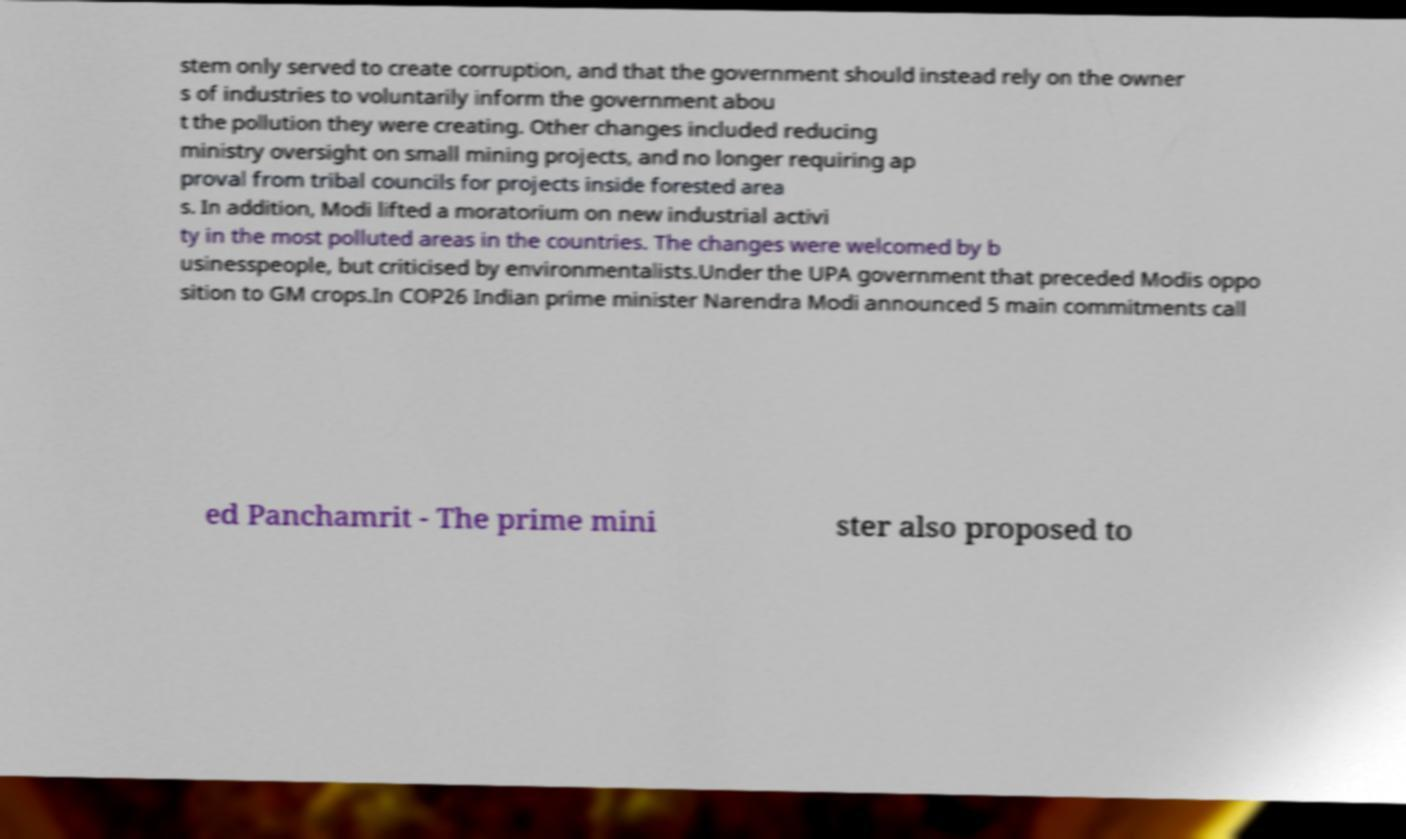There's text embedded in this image that I need extracted. Can you transcribe it verbatim? stem only served to create corruption, and that the government should instead rely on the owner s of industries to voluntarily inform the government abou t the pollution they were creating. Other changes included reducing ministry oversight on small mining projects, and no longer requiring ap proval from tribal councils for projects inside forested area s. In addition, Modi lifted a moratorium on new industrial activi ty in the most polluted areas in the countries. The changes were welcomed by b usinesspeople, but criticised by environmentalists.Under the UPA government that preceded Modis oppo sition to GM crops.In COP26 Indian prime minister Narendra Modi announced 5 main commitments call ed Panchamrit - The prime mini ster also proposed to 